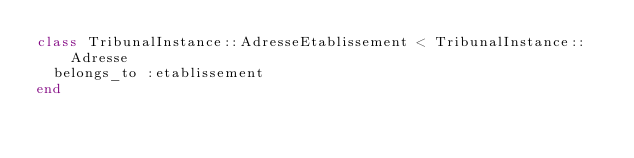Convert code to text. <code><loc_0><loc_0><loc_500><loc_500><_Ruby_>class TribunalInstance::AdresseEtablissement < TribunalInstance::Adresse
  belongs_to :etablissement
end
</code> 